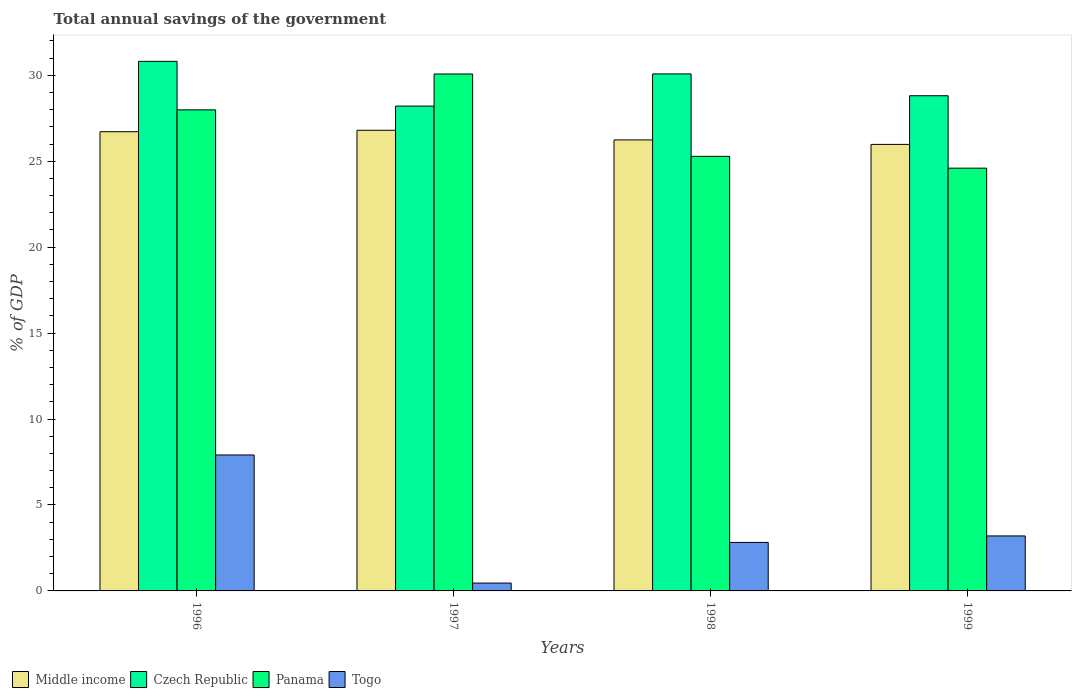How many groups of bars are there?
Make the answer very short. 4. Are the number of bars per tick equal to the number of legend labels?
Offer a very short reply. Yes. Are the number of bars on each tick of the X-axis equal?
Keep it short and to the point. Yes. How many bars are there on the 4th tick from the left?
Your response must be concise. 4. What is the total annual savings of the government in Czech Republic in 1998?
Ensure brevity in your answer.  30.08. Across all years, what is the maximum total annual savings of the government in Czech Republic?
Give a very brief answer. 30.81. Across all years, what is the minimum total annual savings of the government in Panama?
Give a very brief answer. 24.6. In which year was the total annual savings of the government in Panama minimum?
Your answer should be compact. 1999. What is the total total annual savings of the government in Togo in the graph?
Make the answer very short. 14.39. What is the difference between the total annual savings of the government in Czech Republic in 1996 and that in 1998?
Give a very brief answer. 0.73. What is the difference between the total annual savings of the government in Middle income in 1998 and the total annual savings of the government in Czech Republic in 1996?
Give a very brief answer. -4.57. What is the average total annual savings of the government in Czech Republic per year?
Give a very brief answer. 29.48. In the year 1999, what is the difference between the total annual savings of the government in Czech Republic and total annual savings of the government in Togo?
Ensure brevity in your answer.  25.61. In how many years, is the total annual savings of the government in Panama greater than 16 %?
Offer a terse response. 4. What is the ratio of the total annual savings of the government in Czech Republic in 1996 to that in 1997?
Your response must be concise. 1.09. Is the total annual savings of the government in Czech Republic in 1996 less than that in 1997?
Provide a succinct answer. No. Is the difference between the total annual savings of the government in Czech Republic in 1998 and 1999 greater than the difference between the total annual savings of the government in Togo in 1998 and 1999?
Offer a very short reply. Yes. What is the difference between the highest and the second highest total annual savings of the government in Togo?
Offer a terse response. 4.71. What is the difference between the highest and the lowest total annual savings of the government in Czech Republic?
Offer a terse response. 2.6. Is it the case that in every year, the sum of the total annual savings of the government in Middle income and total annual savings of the government in Panama is greater than the sum of total annual savings of the government in Czech Republic and total annual savings of the government in Togo?
Ensure brevity in your answer.  Yes. What does the 4th bar from the right in 1999 represents?
Make the answer very short. Middle income. How many bars are there?
Your answer should be very brief. 16. What is the difference between two consecutive major ticks on the Y-axis?
Provide a short and direct response. 5. Does the graph contain any zero values?
Give a very brief answer. No. Does the graph contain grids?
Your response must be concise. No. How many legend labels are there?
Your response must be concise. 4. How are the legend labels stacked?
Ensure brevity in your answer.  Horizontal. What is the title of the graph?
Provide a succinct answer. Total annual savings of the government. What is the label or title of the X-axis?
Offer a terse response. Years. What is the label or title of the Y-axis?
Make the answer very short. % of GDP. What is the % of GDP of Middle income in 1996?
Provide a short and direct response. 26.72. What is the % of GDP in Czech Republic in 1996?
Make the answer very short. 30.81. What is the % of GDP in Panama in 1996?
Make the answer very short. 27.99. What is the % of GDP of Togo in 1996?
Make the answer very short. 7.91. What is the % of GDP in Middle income in 1997?
Ensure brevity in your answer.  26.8. What is the % of GDP of Czech Republic in 1997?
Keep it short and to the point. 28.21. What is the % of GDP in Panama in 1997?
Offer a very short reply. 30.08. What is the % of GDP of Togo in 1997?
Offer a terse response. 0.46. What is the % of GDP of Middle income in 1998?
Offer a very short reply. 26.24. What is the % of GDP of Czech Republic in 1998?
Offer a very short reply. 30.08. What is the % of GDP in Panama in 1998?
Offer a terse response. 25.29. What is the % of GDP in Togo in 1998?
Your answer should be very brief. 2.82. What is the % of GDP of Middle income in 1999?
Provide a short and direct response. 25.98. What is the % of GDP in Czech Republic in 1999?
Your response must be concise. 28.81. What is the % of GDP in Panama in 1999?
Offer a terse response. 24.6. What is the % of GDP of Togo in 1999?
Offer a very short reply. 3.2. Across all years, what is the maximum % of GDP of Middle income?
Your response must be concise. 26.8. Across all years, what is the maximum % of GDP of Czech Republic?
Keep it short and to the point. 30.81. Across all years, what is the maximum % of GDP in Panama?
Offer a very short reply. 30.08. Across all years, what is the maximum % of GDP in Togo?
Keep it short and to the point. 7.91. Across all years, what is the minimum % of GDP of Middle income?
Provide a short and direct response. 25.98. Across all years, what is the minimum % of GDP in Czech Republic?
Provide a succinct answer. 28.21. Across all years, what is the minimum % of GDP of Panama?
Offer a terse response. 24.6. Across all years, what is the minimum % of GDP in Togo?
Your response must be concise. 0.46. What is the total % of GDP of Middle income in the graph?
Ensure brevity in your answer.  105.74. What is the total % of GDP of Czech Republic in the graph?
Your answer should be very brief. 117.91. What is the total % of GDP in Panama in the graph?
Offer a terse response. 107.95. What is the total % of GDP in Togo in the graph?
Your response must be concise. 14.39. What is the difference between the % of GDP in Middle income in 1996 and that in 1997?
Ensure brevity in your answer.  -0.08. What is the difference between the % of GDP in Czech Republic in 1996 and that in 1997?
Offer a very short reply. 2.6. What is the difference between the % of GDP in Panama in 1996 and that in 1997?
Make the answer very short. -2.09. What is the difference between the % of GDP of Togo in 1996 and that in 1997?
Provide a succinct answer. 7.45. What is the difference between the % of GDP of Middle income in 1996 and that in 1998?
Provide a short and direct response. 0.48. What is the difference between the % of GDP of Czech Republic in 1996 and that in 1998?
Make the answer very short. 0.73. What is the difference between the % of GDP in Panama in 1996 and that in 1998?
Your response must be concise. 2.7. What is the difference between the % of GDP of Togo in 1996 and that in 1998?
Your answer should be compact. 5.09. What is the difference between the % of GDP in Middle income in 1996 and that in 1999?
Your response must be concise. 0.74. What is the difference between the % of GDP of Czech Republic in 1996 and that in 1999?
Ensure brevity in your answer.  2. What is the difference between the % of GDP in Panama in 1996 and that in 1999?
Your response must be concise. 3.39. What is the difference between the % of GDP in Togo in 1996 and that in 1999?
Your response must be concise. 4.71. What is the difference between the % of GDP of Middle income in 1997 and that in 1998?
Keep it short and to the point. 0.56. What is the difference between the % of GDP in Czech Republic in 1997 and that in 1998?
Provide a succinct answer. -1.87. What is the difference between the % of GDP in Panama in 1997 and that in 1998?
Make the answer very short. 4.79. What is the difference between the % of GDP of Togo in 1997 and that in 1998?
Provide a succinct answer. -2.37. What is the difference between the % of GDP in Middle income in 1997 and that in 1999?
Your answer should be compact. 0.82. What is the difference between the % of GDP of Czech Republic in 1997 and that in 1999?
Offer a very short reply. -0.6. What is the difference between the % of GDP of Panama in 1997 and that in 1999?
Keep it short and to the point. 5.48. What is the difference between the % of GDP of Togo in 1997 and that in 1999?
Provide a succinct answer. -2.74. What is the difference between the % of GDP of Middle income in 1998 and that in 1999?
Keep it short and to the point. 0.26. What is the difference between the % of GDP of Czech Republic in 1998 and that in 1999?
Provide a short and direct response. 1.27. What is the difference between the % of GDP in Panama in 1998 and that in 1999?
Offer a terse response. 0.69. What is the difference between the % of GDP in Togo in 1998 and that in 1999?
Offer a very short reply. -0.38. What is the difference between the % of GDP of Middle income in 1996 and the % of GDP of Czech Republic in 1997?
Your answer should be compact. -1.49. What is the difference between the % of GDP of Middle income in 1996 and the % of GDP of Panama in 1997?
Ensure brevity in your answer.  -3.36. What is the difference between the % of GDP of Middle income in 1996 and the % of GDP of Togo in 1997?
Make the answer very short. 26.26. What is the difference between the % of GDP of Czech Republic in 1996 and the % of GDP of Panama in 1997?
Give a very brief answer. 0.73. What is the difference between the % of GDP of Czech Republic in 1996 and the % of GDP of Togo in 1997?
Ensure brevity in your answer.  30.35. What is the difference between the % of GDP in Panama in 1996 and the % of GDP in Togo in 1997?
Provide a short and direct response. 27.53. What is the difference between the % of GDP of Middle income in 1996 and the % of GDP of Czech Republic in 1998?
Your response must be concise. -3.36. What is the difference between the % of GDP of Middle income in 1996 and the % of GDP of Panama in 1998?
Provide a short and direct response. 1.43. What is the difference between the % of GDP of Middle income in 1996 and the % of GDP of Togo in 1998?
Provide a succinct answer. 23.9. What is the difference between the % of GDP in Czech Republic in 1996 and the % of GDP in Panama in 1998?
Keep it short and to the point. 5.53. What is the difference between the % of GDP of Czech Republic in 1996 and the % of GDP of Togo in 1998?
Offer a terse response. 27.99. What is the difference between the % of GDP of Panama in 1996 and the % of GDP of Togo in 1998?
Offer a terse response. 25.17. What is the difference between the % of GDP of Middle income in 1996 and the % of GDP of Czech Republic in 1999?
Your answer should be very brief. -2.09. What is the difference between the % of GDP of Middle income in 1996 and the % of GDP of Panama in 1999?
Make the answer very short. 2.12. What is the difference between the % of GDP in Middle income in 1996 and the % of GDP in Togo in 1999?
Ensure brevity in your answer.  23.52. What is the difference between the % of GDP of Czech Republic in 1996 and the % of GDP of Panama in 1999?
Offer a terse response. 6.21. What is the difference between the % of GDP in Czech Republic in 1996 and the % of GDP in Togo in 1999?
Give a very brief answer. 27.61. What is the difference between the % of GDP of Panama in 1996 and the % of GDP of Togo in 1999?
Provide a short and direct response. 24.79. What is the difference between the % of GDP in Middle income in 1997 and the % of GDP in Czech Republic in 1998?
Give a very brief answer. -3.28. What is the difference between the % of GDP in Middle income in 1997 and the % of GDP in Panama in 1998?
Offer a very short reply. 1.52. What is the difference between the % of GDP in Middle income in 1997 and the % of GDP in Togo in 1998?
Make the answer very short. 23.98. What is the difference between the % of GDP of Czech Republic in 1997 and the % of GDP of Panama in 1998?
Keep it short and to the point. 2.92. What is the difference between the % of GDP in Czech Republic in 1997 and the % of GDP in Togo in 1998?
Provide a succinct answer. 25.39. What is the difference between the % of GDP in Panama in 1997 and the % of GDP in Togo in 1998?
Make the answer very short. 27.25. What is the difference between the % of GDP in Middle income in 1997 and the % of GDP in Czech Republic in 1999?
Your answer should be very brief. -2.01. What is the difference between the % of GDP in Middle income in 1997 and the % of GDP in Panama in 1999?
Your answer should be compact. 2.2. What is the difference between the % of GDP in Middle income in 1997 and the % of GDP in Togo in 1999?
Your answer should be very brief. 23.6. What is the difference between the % of GDP in Czech Republic in 1997 and the % of GDP in Panama in 1999?
Your answer should be compact. 3.61. What is the difference between the % of GDP of Czech Republic in 1997 and the % of GDP of Togo in 1999?
Your answer should be very brief. 25.01. What is the difference between the % of GDP in Panama in 1997 and the % of GDP in Togo in 1999?
Your answer should be compact. 26.88. What is the difference between the % of GDP of Middle income in 1998 and the % of GDP of Czech Republic in 1999?
Ensure brevity in your answer.  -2.57. What is the difference between the % of GDP of Middle income in 1998 and the % of GDP of Panama in 1999?
Offer a terse response. 1.64. What is the difference between the % of GDP in Middle income in 1998 and the % of GDP in Togo in 1999?
Ensure brevity in your answer.  23.04. What is the difference between the % of GDP of Czech Republic in 1998 and the % of GDP of Panama in 1999?
Offer a very short reply. 5.48. What is the difference between the % of GDP in Czech Republic in 1998 and the % of GDP in Togo in 1999?
Provide a succinct answer. 26.88. What is the difference between the % of GDP in Panama in 1998 and the % of GDP in Togo in 1999?
Your answer should be compact. 22.09. What is the average % of GDP of Middle income per year?
Offer a very short reply. 26.43. What is the average % of GDP of Czech Republic per year?
Give a very brief answer. 29.48. What is the average % of GDP in Panama per year?
Make the answer very short. 26.99. What is the average % of GDP in Togo per year?
Provide a succinct answer. 3.6. In the year 1996, what is the difference between the % of GDP of Middle income and % of GDP of Czech Republic?
Make the answer very short. -4.09. In the year 1996, what is the difference between the % of GDP of Middle income and % of GDP of Panama?
Provide a succinct answer. -1.27. In the year 1996, what is the difference between the % of GDP of Middle income and % of GDP of Togo?
Provide a succinct answer. 18.81. In the year 1996, what is the difference between the % of GDP of Czech Republic and % of GDP of Panama?
Your answer should be very brief. 2.82. In the year 1996, what is the difference between the % of GDP of Czech Republic and % of GDP of Togo?
Offer a terse response. 22.9. In the year 1996, what is the difference between the % of GDP in Panama and % of GDP in Togo?
Provide a succinct answer. 20.08. In the year 1997, what is the difference between the % of GDP in Middle income and % of GDP in Czech Republic?
Your answer should be very brief. -1.41. In the year 1997, what is the difference between the % of GDP of Middle income and % of GDP of Panama?
Your answer should be compact. -3.28. In the year 1997, what is the difference between the % of GDP in Middle income and % of GDP in Togo?
Make the answer very short. 26.34. In the year 1997, what is the difference between the % of GDP of Czech Republic and % of GDP of Panama?
Your answer should be very brief. -1.87. In the year 1997, what is the difference between the % of GDP in Czech Republic and % of GDP in Togo?
Provide a succinct answer. 27.75. In the year 1997, what is the difference between the % of GDP in Panama and % of GDP in Togo?
Keep it short and to the point. 29.62. In the year 1998, what is the difference between the % of GDP of Middle income and % of GDP of Czech Republic?
Make the answer very short. -3.84. In the year 1998, what is the difference between the % of GDP in Middle income and % of GDP in Panama?
Offer a very short reply. 0.96. In the year 1998, what is the difference between the % of GDP in Middle income and % of GDP in Togo?
Give a very brief answer. 23.42. In the year 1998, what is the difference between the % of GDP in Czech Republic and % of GDP in Panama?
Offer a very short reply. 4.8. In the year 1998, what is the difference between the % of GDP in Czech Republic and % of GDP in Togo?
Your response must be concise. 27.26. In the year 1998, what is the difference between the % of GDP of Panama and % of GDP of Togo?
Keep it short and to the point. 22.46. In the year 1999, what is the difference between the % of GDP of Middle income and % of GDP of Czech Republic?
Offer a terse response. -2.83. In the year 1999, what is the difference between the % of GDP in Middle income and % of GDP in Panama?
Provide a short and direct response. 1.38. In the year 1999, what is the difference between the % of GDP of Middle income and % of GDP of Togo?
Your answer should be compact. 22.78. In the year 1999, what is the difference between the % of GDP in Czech Republic and % of GDP in Panama?
Ensure brevity in your answer.  4.21. In the year 1999, what is the difference between the % of GDP in Czech Republic and % of GDP in Togo?
Offer a very short reply. 25.61. In the year 1999, what is the difference between the % of GDP in Panama and % of GDP in Togo?
Offer a terse response. 21.4. What is the ratio of the % of GDP of Czech Republic in 1996 to that in 1997?
Give a very brief answer. 1.09. What is the ratio of the % of GDP in Panama in 1996 to that in 1997?
Provide a short and direct response. 0.93. What is the ratio of the % of GDP in Togo in 1996 to that in 1997?
Offer a terse response. 17.31. What is the ratio of the % of GDP in Middle income in 1996 to that in 1998?
Keep it short and to the point. 1.02. What is the ratio of the % of GDP in Czech Republic in 1996 to that in 1998?
Offer a terse response. 1.02. What is the ratio of the % of GDP of Panama in 1996 to that in 1998?
Make the answer very short. 1.11. What is the ratio of the % of GDP in Togo in 1996 to that in 1998?
Provide a short and direct response. 2.8. What is the ratio of the % of GDP of Middle income in 1996 to that in 1999?
Give a very brief answer. 1.03. What is the ratio of the % of GDP of Czech Republic in 1996 to that in 1999?
Ensure brevity in your answer.  1.07. What is the ratio of the % of GDP of Panama in 1996 to that in 1999?
Ensure brevity in your answer.  1.14. What is the ratio of the % of GDP of Togo in 1996 to that in 1999?
Provide a short and direct response. 2.47. What is the ratio of the % of GDP in Middle income in 1997 to that in 1998?
Offer a very short reply. 1.02. What is the ratio of the % of GDP in Czech Republic in 1997 to that in 1998?
Provide a short and direct response. 0.94. What is the ratio of the % of GDP in Panama in 1997 to that in 1998?
Keep it short and to the point. 1.19. What is the ratio of the % of GDP of Togo in 1997 to that in 1998?
Your answer should be very brief. 0.16. What is the ratio of the % of GDP of Middle income in 1997 to that in 1999?
Offer a terse response. 1.03. What is the ratio of the % of GDP in Czech Republic in 1997 to that in 1999?
Ensure brevity in your answer.  0.98. What is the ratio of the % of GDP of Panama in 1997 to that in 1999?
Ensure brevity in your answer.  1.22. What is the ratio of the % of GDP in Togo in 1997 to that in 1999?
Ensure brevity in your answer.  0.14. What is the ratio of the % of GDP in Czech Republic in 1998 to that in 1999?
Keep it short and to the point. 1.04. What is the ratio of the % of GDP in Panama in 1998 to that in 1999?
Ensure brevity in your answer.  1.03. What is the ratio of the % of GDP in Togo in 1998 to that in 1999?
Your answer should be very brief. 0.88. What is the difference between the highest and the second highest % of GDP of Middle income?
Offer a terse response. 0.08. What is the difference between the highest and the second highest % of GDP of Czech Republic?
Keep it short and to the point. 0.73. What is the difference between the highest and the second highest % of GDP in Panama?
Make the answer very short. 2.09. What is the difference between the highest and the second highest % of GDP of Togo?
Give a very brief answer. 4.71. What is the difference between the highest and the lowest % of GDP of Middle income?
Provide a succinct answer. 0.82. What is the difference between the highest and the lowest % of GDP of Czech Republic?
Ensure brevity in your answer.  2.6. What is the difference between the highest and the lowest % of GDP in Panama?
Offer a very short reply. 5.48. What is the difference between the highest and the lowest % of GDP in Togo?
Your answer should be very brief. 7.45. 